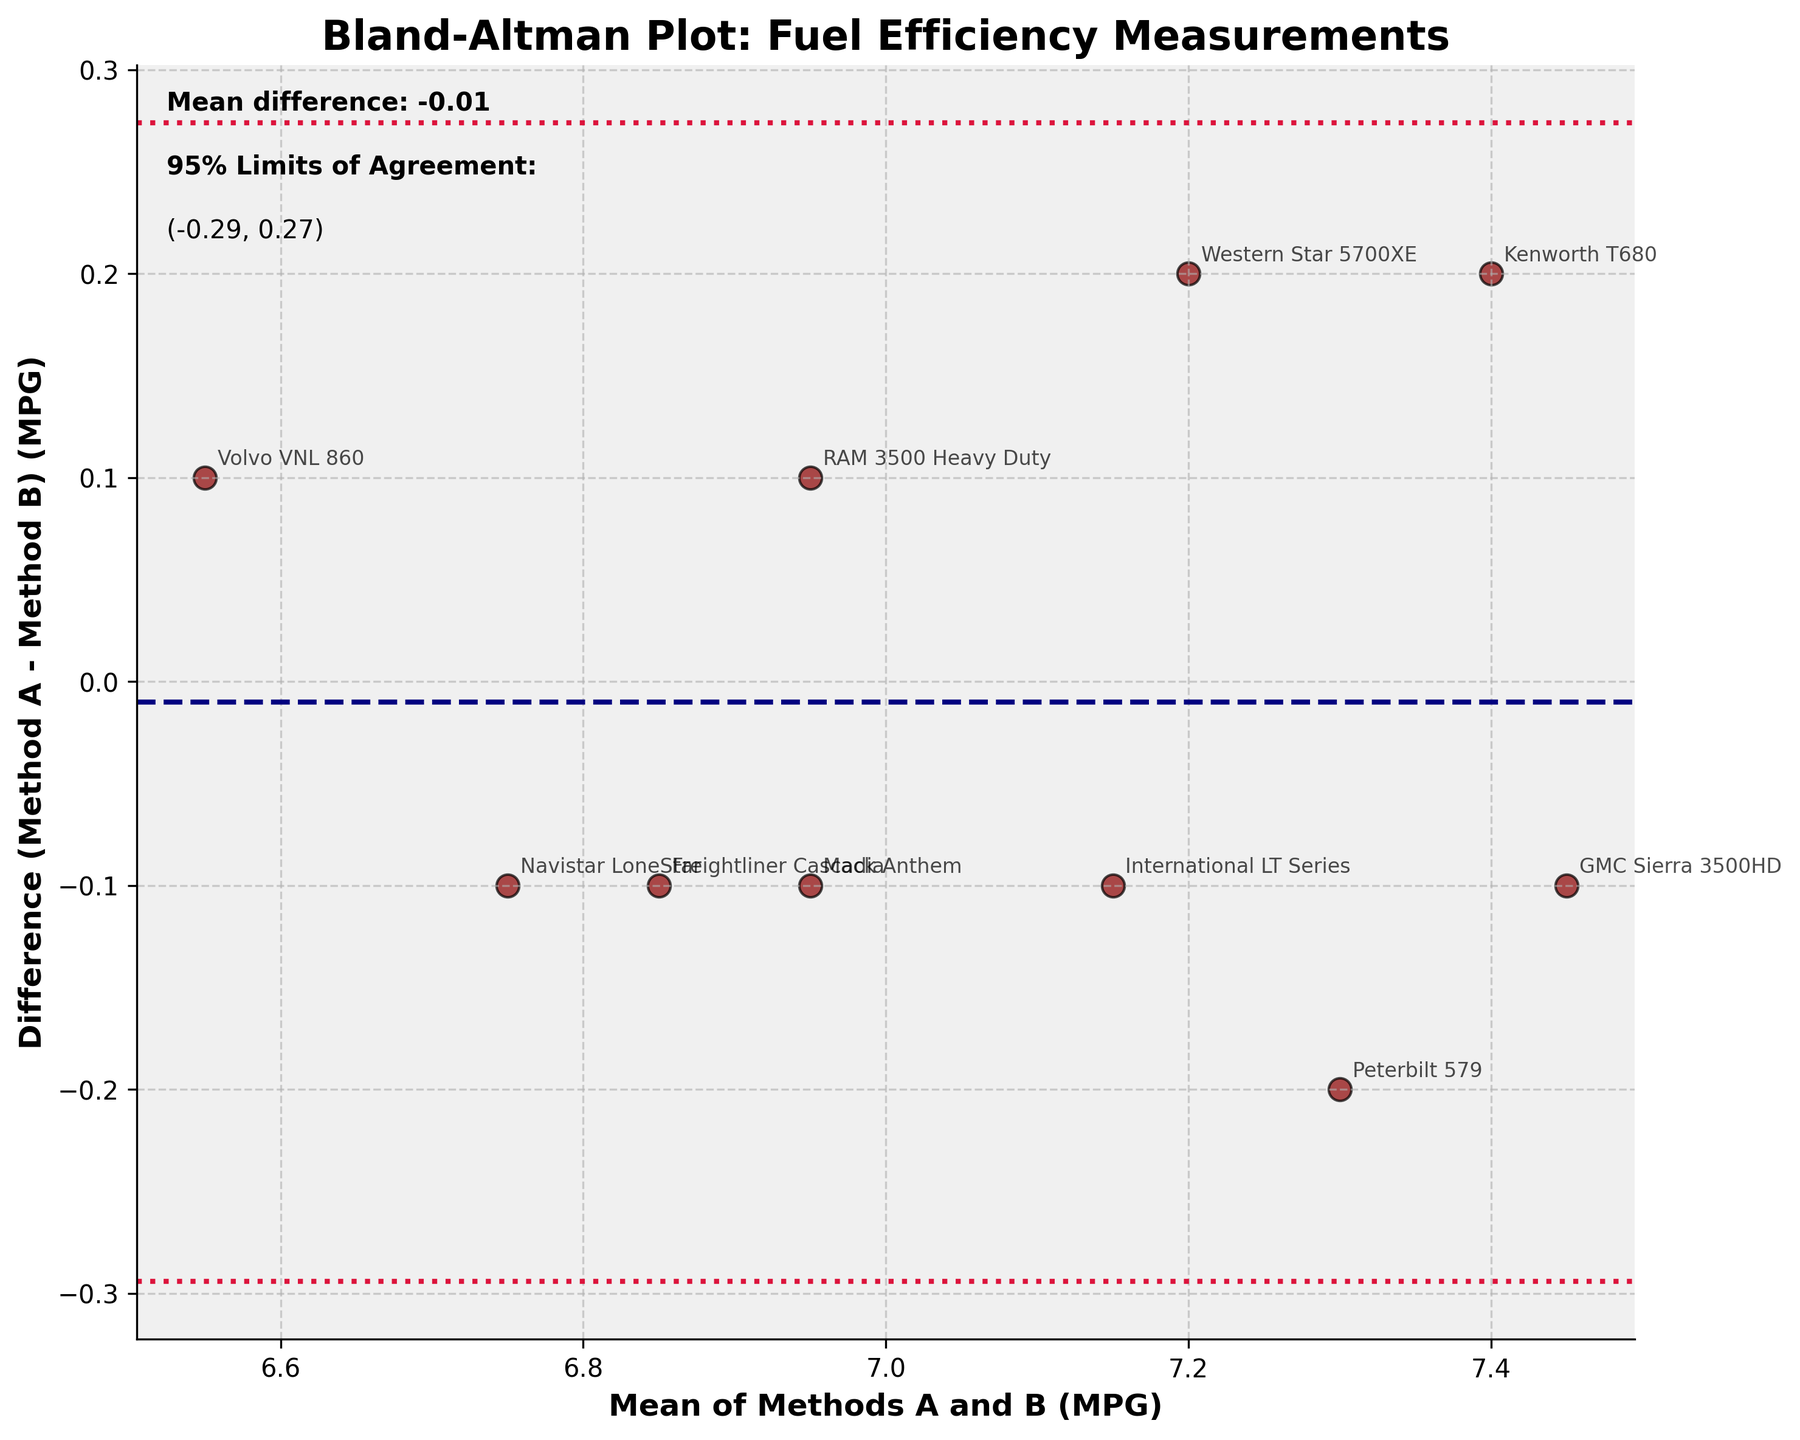What's the title of the plot? The title of the plot is located at the top of the figure. It reads "Bland-Altman Plot: Fuel Efficiency Measurements".
Answer: Bland-Altman Plot: Fuel Efficiency Measurements How many trucks' data points are shown in the plot? Count each individual data point in the scatter plot. There are 10 data points representing 10 trucks.
Answer: 10 What are the x-axis and y-axis labels? Look at the labels on each axis. The x-axis label is "Mean of Methods A and B (MPG)", and the y-axis label is "Difference (Method A - Method B) (MPG)".
Answer: Mean of Methods A and B (MPG) and Difference (Method A - Method B) (MPG) What's the mean difference between Method A and Method B? The mean difference is indicated by the horizontal dashed line and the text on the top left of the plot. It reads "Mean difference: -0.02".
Answer: -0.02 What are the 95% limits of agreement? The 95% limits of agreement are shown as two horizontal dotted lines on the plot, and specified in the text on the top left of the plot. They are (-0.30, 0.26).
Answer: (-0.30, 0.26) Which truck model has the highest mean MPG between the two methods? Look at the x-axis values to identify the data point with the highest mean MPG. The truck labeled "GMC Sierra 3500HD" appears at the highest point on the x-axis.
Answer: GMC Sierra 3500HD Is there any truck model with a difference in MPG greater than the limits of agreement? Check if any data points fall outside the horizontal dotted lines (limits of agreement). All data points are within the limits of agreement.
Answer: No Which truck model shows the largest positive difference in MPG between Method A and Method B? Find the data point with the highest positive y-value (y-axis, difference), which is the "Peterbilt 579".
Answer: Peterbilt 579 Which truck model shows the largest negative difference in MPG between Method A and Method B? Find the data point with the lowest negative y-value (y-axis, difference), which is the "Kenworth T680".
Answer: Kenworth T680 Is the difference between Method A and Method B consistent across trucks? Evaluate the spread of data points along the y-axis (difference). Differences vary around the mean difference, indicating variability among trucks.
Answer: No 